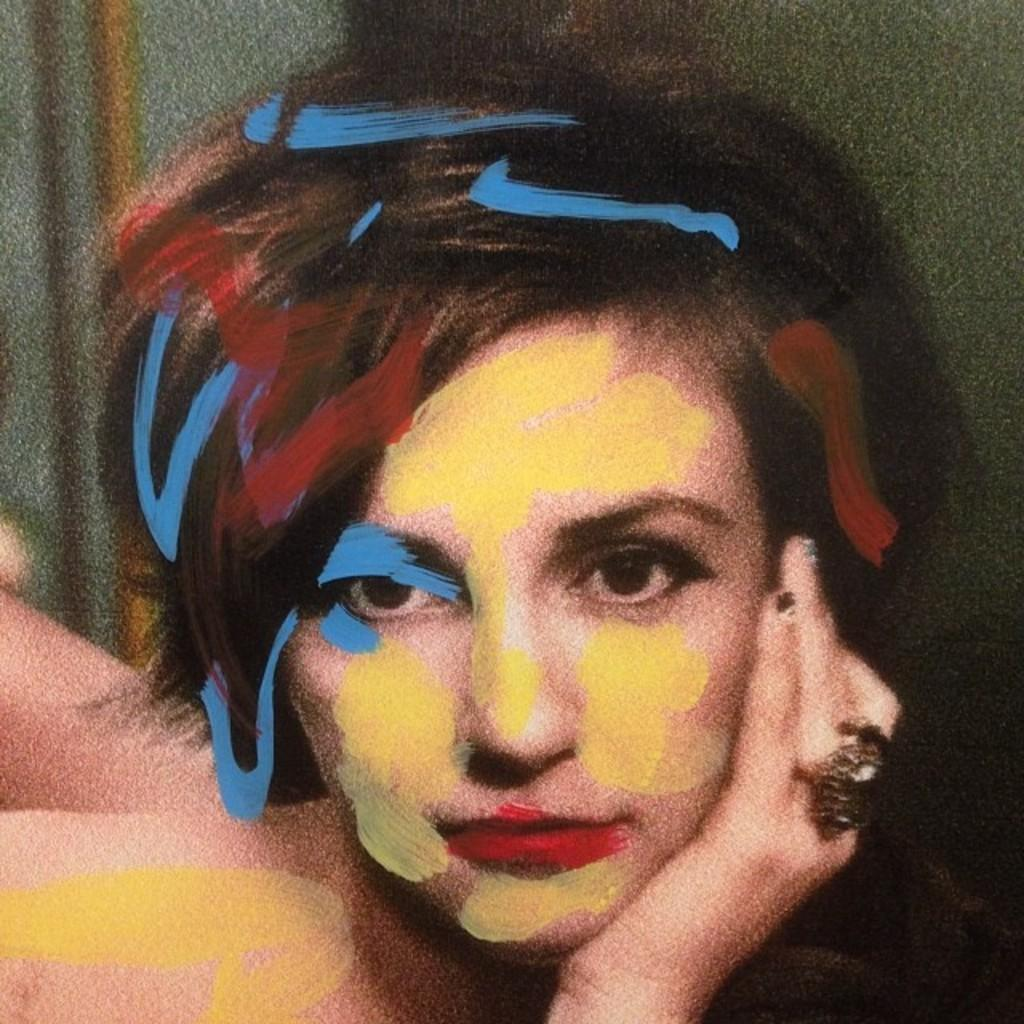Who is the main subject in the picture? There is a woman in the picture. What is unique about the woman's appearance? The woman has a painting on her face. How would you describe the quality of the image? The image is slightly blurred. What type of oil is being used by the lawyer in the image? There is no lawyer or oil present in the image; it features a woman with a painting on her face. What season is depicted in the image? The image does not depict a specific season; it is focused on the woman with the painting on her face. 